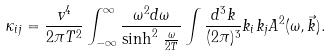Convert formula to latex. <formula><loc_0><loc_0><loc_500><loc_500>\kappa _ { i j } = \frac { v ^ { 4 } } { 2 \pi T ^ { 2 } } \int _ { - \infty } ^ { \infty } \frac { \omega ^ { 2 } d \omega } { \sinh ^ { 2 } \, \frac { \omega } { 2 T } } \int \frac { d ^ { 3 } k } { ( 2 \pi ) ^ { 3 } } k _ { i } k _ { j } A ^ { 2 } ( \omega , \vec { k } ) .</formula> 